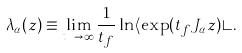<formula> <loc_0><loc_0><loc_500><loc_500>\lambda _ { \alpha } ( z ) \equiv \lim _ { t _ { f } \to \infty } \frac { 1 } { t _ { f } } \ln \langle \exp ( t _ { f } J _ { \alpha } z ) \rangle .</formula> 